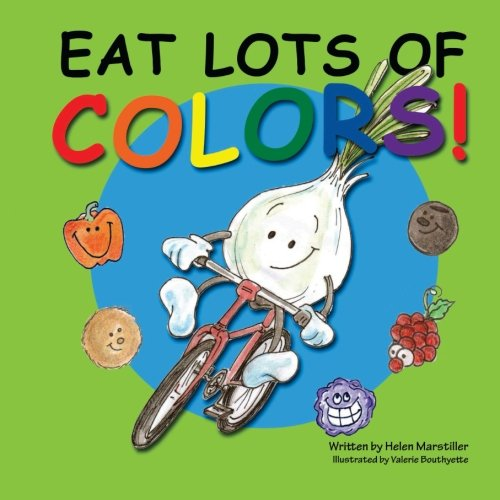What type of book is this? This is a children's book that combines elements of fun and education to teach kids about healthy eating habits through colorful illustrations and simple narratives. 